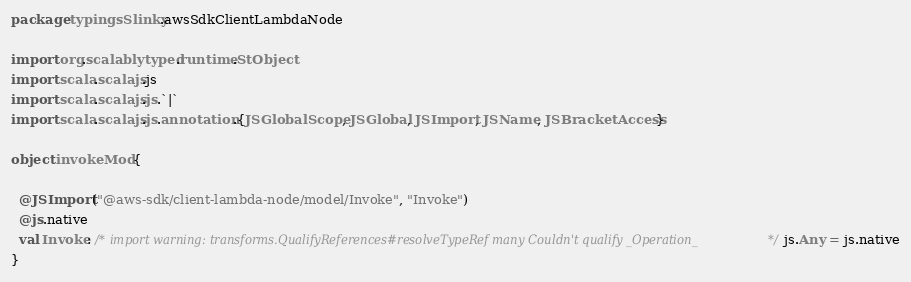<code> <loc_0><loc_0><loc_500><loc_500><_Scala_>package typingsSlinky.awsSdkClientLambdaNode

import org.scalablytyped.runtime.StObject
import scala.scalajs.js
import scala.scalajs.js.`|`
import scala.scalajs.js.annotation.{JSGlobalScope, JSGlobal, JSImport, JSName, JSBracketAccess}

object invokeMod {
  
  @JSImport("@aws-sdk/client-lambda-node/model/Invoke", "Invoke")
  @js.native
  val Invoke: /* import warning: transforms.QualifyReferences#resolveTypeRef many Couldn't qualify _Operation_ */ js.Any = js.native
}
</code> 